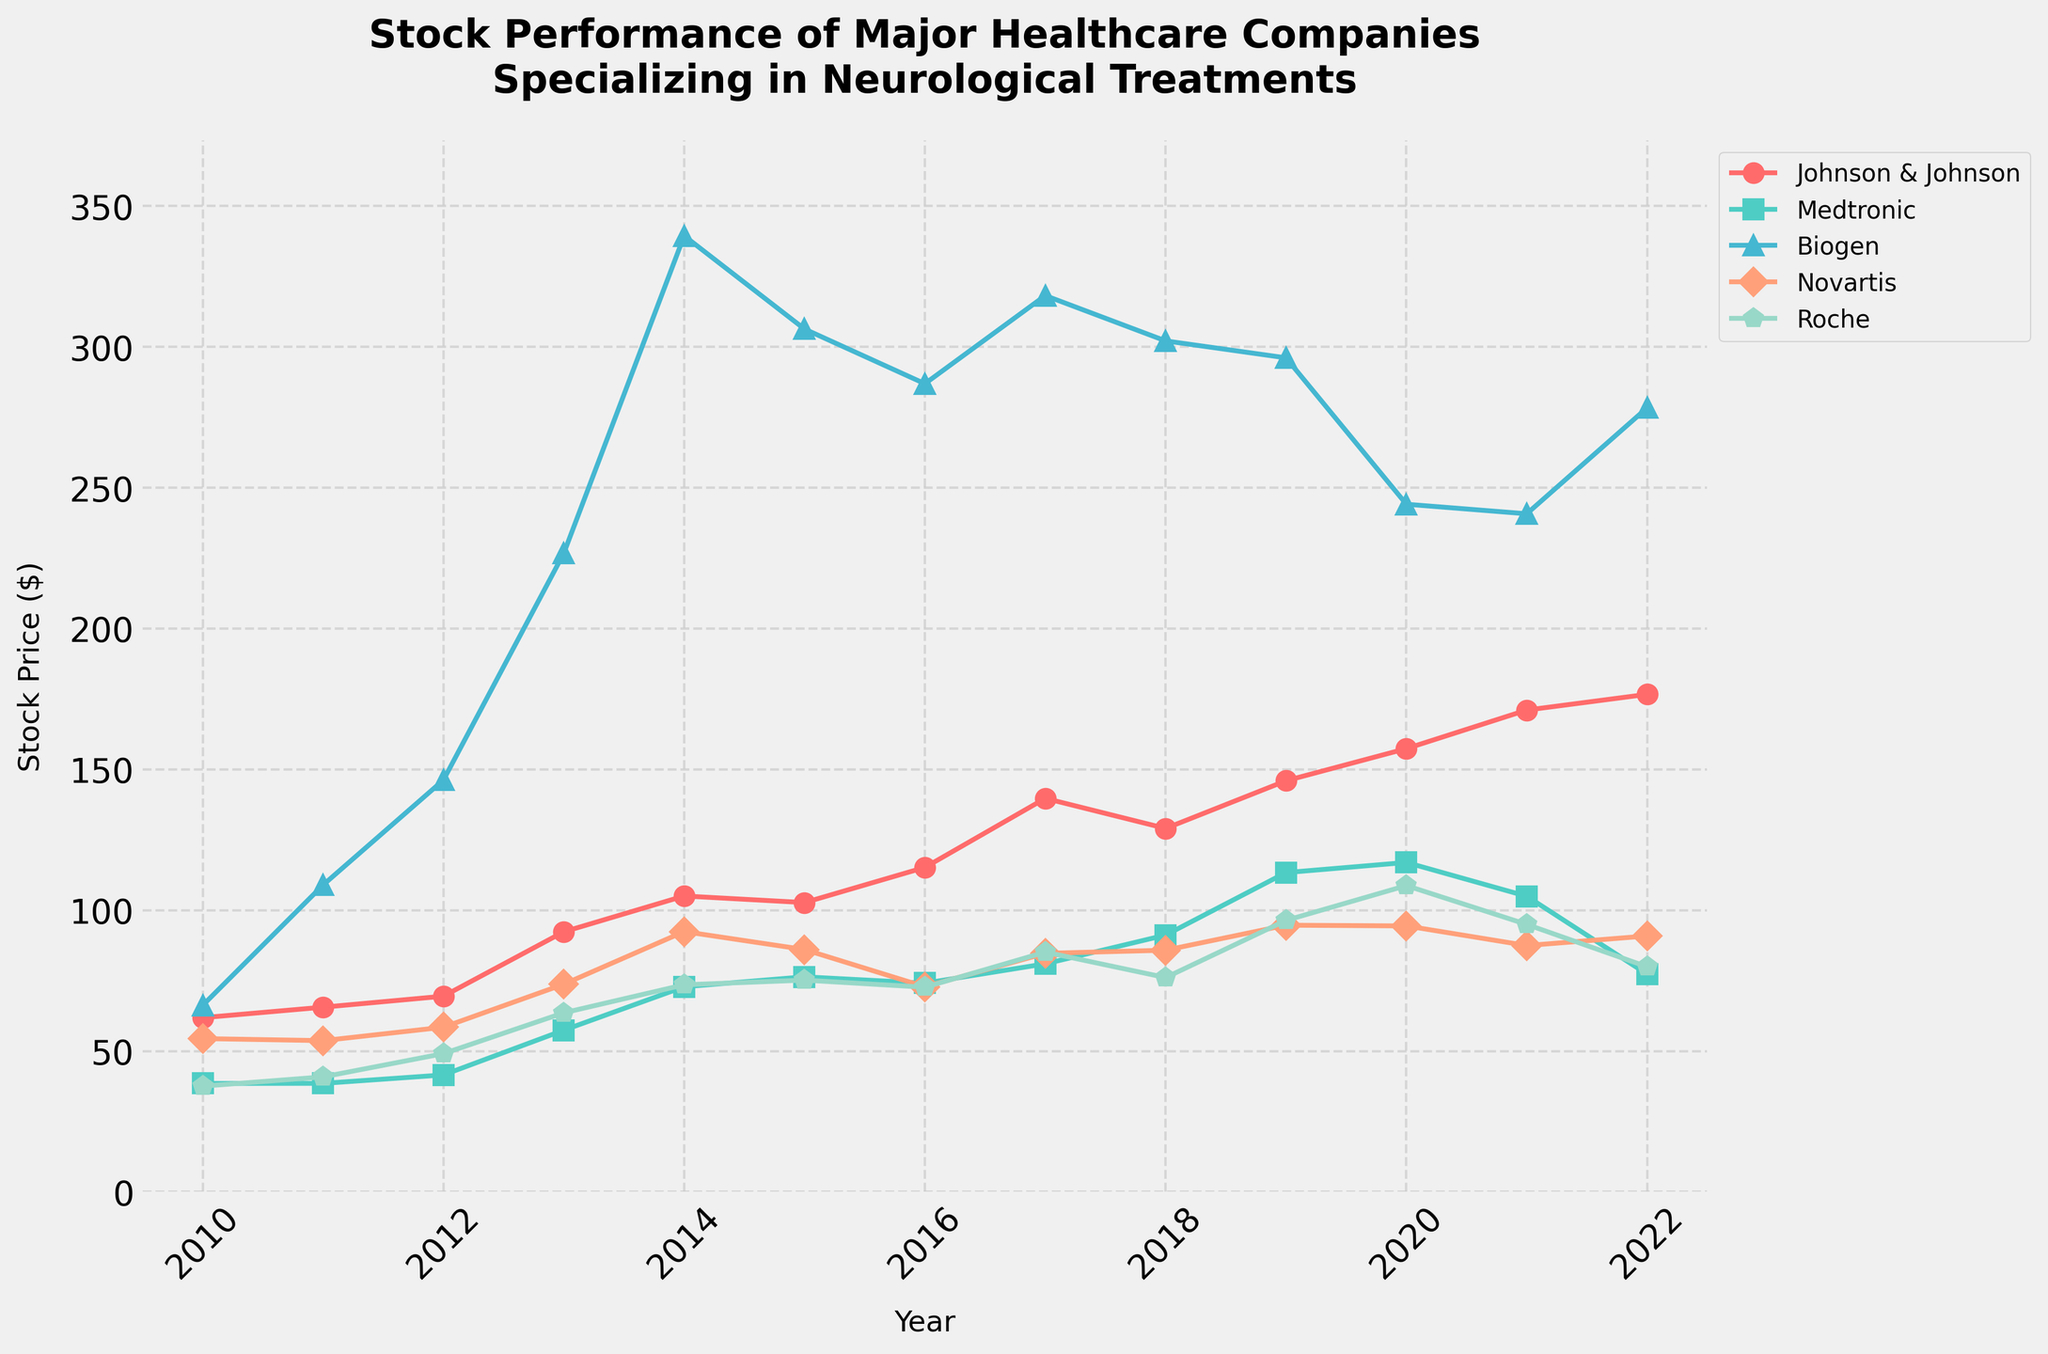What is the stock price of Johnson & Johnson in the year 2013? Look for the point on the line plot corresponding to Johnson & Johnson in 2013. The stock price is represented on the y-axis.
Answer: 92.35 Which healthcare company had the highest stock price in 2020? Find the points on the plot for the year 2020. Compare all five companies' stock prices for that year.
Answer: Johnson & Johnson How did Biogen's stock price change from 2011 to 2014? Locate Biogen's stock prices in 2011 and 2014 from the plot and subtract the earlier value from the latter one.
Answer: Increased by 230.49 Which company's stock price declined the most between 2021 and 2022? Calculate the difference in stock prices for 2021 and 2022 for each company, then identify the largest decrease.
Answer: Medtronic What was the average stock price of Roche from 2010 to 2022? Sum Roche's stock prices from 2010 to 2022 and divide by the number of years (13).
Answer: 69.72 Which company had the most consistent stock price growth from 2010 to 2022? Examine the slope and variability of each company's line plot over the years. The company with the steadiest slope likely had the most consistent growth.
Answer: Johnson & Johnson How many companies had their stock price peak in 2017? Look at the peaks of all company lines in 2017 and count how many companies reached their highest point that year.
Answer: Two (Medtronic, Roche) What color is used to represent Medtronic's stock price? Identify the color of the line used for Medtronic from the plot legend.
Answer: Green Which two companies had nearly identical stock prices in 2018? Compare the stock prices of all companies in 2018 and find the two closest values.
Answer: Novartis and Roche Did the stock prices of Novartis and Roche both increase or decrease overall from 2010 to 2022? Examine the starting and ending points of the lines for Novartis and Roche. Determine whether both lines move upwards or downwards.
Answer: Increased 